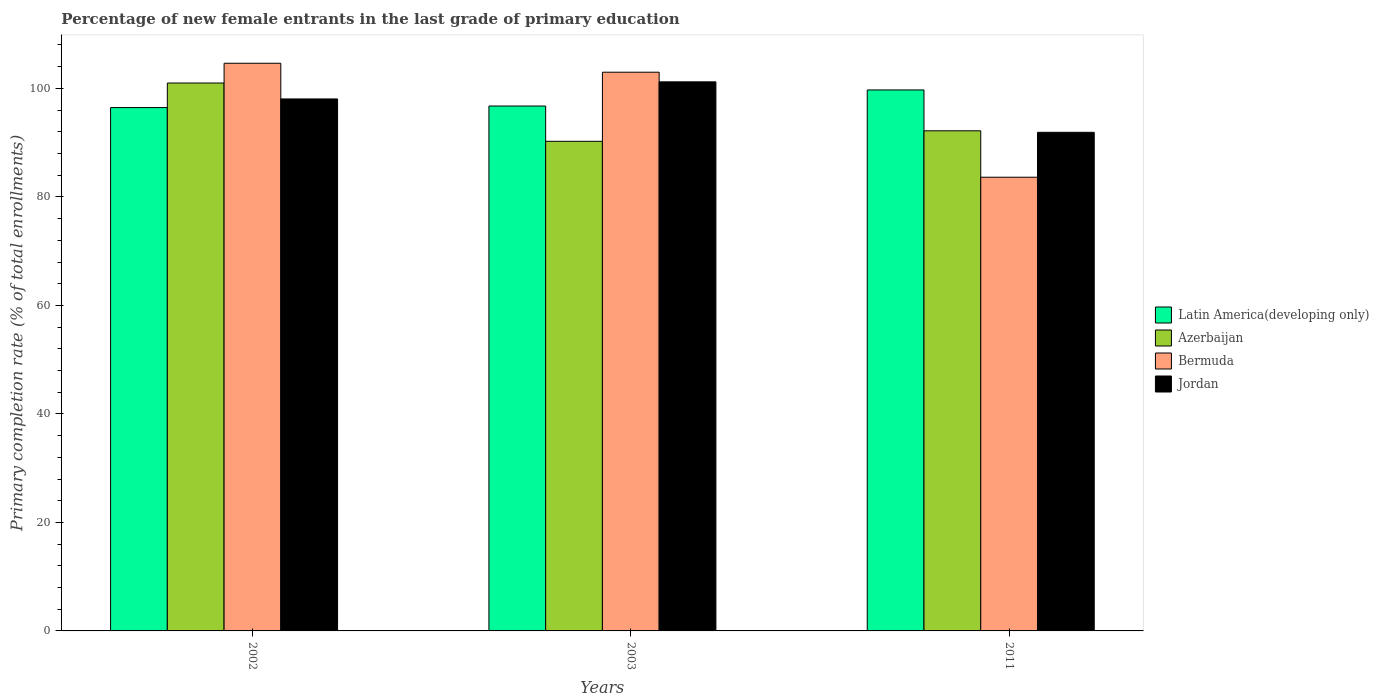How many groups of bars are there?
Offer a terse response. 3. How many bars are there on the 3rd tick from the right?
Offer a terse response. 4. What is the label of the 2nd group of bars from the left?
Keep it short and to the point. 2003. In how many cases, is the number of bars for a given year not equal to the number of legend labels?
Make the answer very short. 0. What is the percentage of new female entrants in Azerbaijan in 2002?
Ensure brevity in your answer.  100.99. Across all years, what is the maximum percentage of new female entrants in Latin America(developing only)?
Your answer should be compact. 99.72. Across all years, what is the minimum percentage of new female entrants in Jordan?
Your answer should be very brief. 91.91. In which year was the percentage of new female entrants in Jordan maximum?
Ensure brevity in your answer.  2003. In which year was the percentage of new female entrants in Latin America(developing only) minimum?
Offer a very short reply. 2002. What is the total percentage of new female entrants in Jordan in the graph?
Give a very brief answer. 291.17. What is the difference between the percentage of new female entrants in Latin America(developing only) in 2003 and that in 2011?
Your answer should be compact. -2.96. What is the difference between the percentage of new female entrants in Jordan in 2011 and the percentage of new female entrants in Bermuda in 2003?
Your answer should be very brief. -11.08. What is the average percentage of new female entrants in Bermuda per year?
Your answer should be compact. 97.08. In the year 2002, what is the difference between the percentage of new female entrants in Bermuda and percentage of new female entrants in Latin America(developing only)?
Your answer should be very brief. 8.17. What is the ratio of the percentage of new female entrants in Azerbaijan in 2002 to that in 2011?
Your answer should be very brief. 1.1. Is the percentage of new female entrants in Bermuda in 2003 less than that in 2011?
Your answer should be very brief. No. What is the difference between the highest and the second highest percentage of new female entrants in Azerbaijan?
Your response must be concise. 8.81. What is the difference between the highest and the lowest percentage of new female entrants in Azerbaijan?
Provide a succinct answer. 10.74. Is the sum of the percentage of new female entrants in Latin America(developing only) in 2003 and 2011 greater than the maximum percentage of new female entrants in Azerbaijan across all years?
Your answer should be very brief. Yes. Is it the case that in every year, the sum of the percentage of new female entrants in Azerbaijan and percentage of new female entrants in Bermuda is greater than the sum of percentage of new female entrants in Jordan and percentage of new female entrants in Latin America(developing only)?
Your answer should be compact. No. What does the 2nd bar from the left in 2002 represents?
Ensure brevity in your answer.  Azerbaijan. What does the 3rd bar from the right in 2003 represents?
Your answer should be compact. Azerbaijan. How many bars are there?
Keep it short and to the point. 12. Are all the bars in the graph horizontal?
Make the answer very short. No. How are the legend labels stacked?
Keep it short and to the point. Vertical. What is the title of the graph?
Your answer should be compact. Percentage of new female entrants in the last grade of primary education. What is the label or title of the X-axis?
Provide a short and direct response. Years. What is the label or title of the Y-axis?
Make the answer very short. Primary completion rate (% of total enrollments). What is the Primary completion rate (% of total enrollments) in Latin America(developing only) in 2002?
Ensure brevity in your answer.  96.47. What is the Primary completion rate (% of total enrollments) in Azerbaijan in 2002?
Your response must be concise. 100.99. What is the Primary completion rate (% of total enrollments) of Bermuda in 2002?
Make the answer very short. 104.63. What is the Primary completion rate (% of total enrollments) in Jordan in 2002?
Your answer should be compact. 98.06. What is the Primary completion rate (% of total enrollments) of Latin America(developing only) in 2003?
Ensure brevity in your answer.  96.75. What is the Primary completion rate (% of total enrollments) of Azerbaijan in 2003?
Ensure brevity in your answer.  90.25. What is the Primary completion rate (% of total enrollments) in Bermuda in 2003?
Ensure brevity in your answer.  102.99. What is the Primary completion rate (% of total enrollments) in Jordan in 2003?
Provide a short and direct response. 101.21. What is the Primary completion rate (% of total enrollments) of Latin America(developing only) in 2011?
Provide a succinct answer. 99.72. What is the Primary completion rate (% of total enrollments) of Azerbaijan in 2011?
Your response must be concise. 92.18. What is the Primary completion rate (% of total enrollments) of Bermuda in 2011?
Your answer should be compact. 83.63. What is the Primary completion rate (% of total enrollments) of Jordan in 2011?
Make the answer very short. 91.91. Across all years, what is the maximum Primary completion rate (% of total enrollments) in Latin America(developing only)?
Make the answer very short. 99.72. Across all years, what is the maximum Primary completion rate (% of total enrollments) of Azerbaijan?
Your answer should be compact. 100.99. Across all years, what is the maximum Primary completion rate (% of total enrollments) of Bermuda?
Offer a very short reply. 104.63. Across all years, what is the maximum Primary completion rate (% of total enrollments) in Jordan?
Your answer should be very brief. 101.21. Across all years, what is the minimum Primary completion rate (% of total enrollments) in Latin America(developing only)?
Your answer should be very brief. 96.47. Across all years, what is the minimum Primary completion rate (% of total enrollments) in Azerbaijan?
Provide a succinct answer. 90.25. Across all years, what is the minimum Primary completion rate (% of total enrollments) in Bermuda?
Your answer should be very brief. 83.63. Across all years, what is the minimum Primary completion rate (% of total enrollments) in Jordan?
Keep it short and to the point. 91.91. What is the total Primary completion rate (% of total enrollments) of Latin America(developing only) in the graph?
Keep it short and to the point. 292.93. What is the total Primary completion rate (% of total enrollments) in Azerbaijan in the graph?
Keep it short and to the point. 283.42. What is the total Primary completion rate (% of total enrollments) of Bermuda in the graph?
Make the answer very short. 291.25. What is the total Primary completion rate (% of total enrollments) in Jordan in the graph?
Provide a short and direct response. 291.17. What is the difference between the Primary completion rate (% of total enrollments) in Latin America(developing only) in 2002 and that in 2003?
Your response must be concise. -0.29. What is the difference between the Primary completion rate (% of total enrollments) in Azerbaijan in 2002 and that in 2003?
Offer a terse response. 10.74. What is the difference between the Primary completion rate (% of total enrollments) of Bermuda in 2002 and that in 2003?
Offer a very short reply. 1.65. What is the difference between the Primary completion rate (% of total enrollments) in Jordan in 2002 and that in 2003?
Offer a terse response. -3.15. What is the difference between the Primary completion rate (% of total enrollments) of Latin America(developing only) in 2002 and that in 2011?
Offer a terse response. -3.25. What is the difference between the Primary completion rate (% of total enrollments) in Azerbaijan in 2002 and that in 2011?
Keep it short and to the point. 8.81. What is the difference between the Primary completion rate (% of total enrollments) in Bermuda in 2002 and that in 2011?
Offer a terse response. 21.01. What is the difference between the Primary completion rate (% of total enrollments) of Jordan in 2002 and that in 2011?
Make the answer very short. 6.15. What is the difference between the Primary completion rate (% of total enrollments) in Latin America(developing only) in 2003 and that in 2011?
Your answer should be very brief. -2.96. What is the difference between the Primary completion rate (% of total enrollments) in Azerbaijan in 2003 and that in 2011?
Make the answer very short. -1.94. What is the difference between the Primary completion rate (% of total enrollments) of Bermuda in 2003 and that in 2011?
Offer a very short reply. 19.36. What is the difference between the Primary completion rate (% of total enrollments) in Jordan in 2003 and that in 2011?
Offer a very short reply. 9.3. What is the difference between the Primary completion rate (% of total enrollments) in Latin America(developing only) in 2002 and the Primary completion rate (% of total enrollments) in Azerbaijan in 2003?
Provide a succinct answer. 6.22. What is the difference between the Primary completion rate (% of total enrollments) in Latin America(developing only) in 2002 and the Primary completion rate (% of total enrollments) in Bermuda in 2003?
Ensure brevity in your answer.  -6.52. What is the difference between the Primary completion rate (% of total enrollments) of Latin America(developing only) in 2002 and the Primary completion rate (% of total enrollments) of Jordan in 2003?
Keep it short and to the point. -4.74. What is the difference between the Primary completion rate (% of total enrollments) of Azerbaijan in 2002 and the Primary completion rate (% of total enrollments) of Bermuda in 2003?
Offer a terse response. -1.99. What is the difference between the Primary completion rate (% of total enrollments) of Azerbaijan in 2002 and the Primary completion rate (% of total enrollments) of Jordan in 2003?
Give a very brief answer. -0.22. What is the difference between the Primary completion rate (% of total enrollments) of Bermuda in 2002 and the Primary completion rate (% of total enrollments) of Jordan in 2003?
Your answer should be very brief. 3.43. What is the difference between the Primary completion rate (% of total enrollments) of Latin America(developing only) in 2002 and the Primary completion rate (% of total enrollments) of Azerbaijan in 2011?
Your response must be concise. 4.28. What is the difference between the Primary completion rate (% of total enrollments) in Latin America(developing only) in 2002 and the Primary completion rate (% of total enrollments) in Bermuda in 2011?
Give a very brief answer. 12.84. What is the difference between the Primary completion rate (% of total enrollments) of Latin America(developing only) in 2002 and the Primary completion rate (% of total enrollments) of Jordan in 2011?
Offer a terse response. 4.56. What is the difference between the Primary completion rate (% of total enrollments) of Azerbaijan in 2002 and the Primary completion rate (% of total enrollments) of Bermuda in 2011?
Offer a terse response. 17.36. What is the difference between the Primary completion rate (% of total enrollments) in Azerbaijan in 2002 and the Primary completion rate (% of total enrollments) in Jordan in 2011?
Your answer should be very brief. 9.09. What is the difference between the Primary completion rate (% of total enrollments) of Bermuda in 2002 and the Primary completion rate (% of total enrollments) of Jordan in 2011?
Offer a terse response. 12.73. What is the difference between the Primary completion rate (% of total enrollments) of Latin America(developing only) in 2003 and the Primary completion rate (% of total enrollments) of Azerbaijan in 2011?
Provide a short and direct response. 4.57. What is the difference between the Primary completion rate (% of total enrollments) of Latin America(developing only) in 2003 and the Primary completion rate (% of total enrollments) of Bermuda in 2011?
Offer a terse response. 13.12. What is the difference between the Primary completion rate (% of total enrollments) in Latin America(developing only) in 2003 and the Primary completion rate (% of total enrollments) in Jordan in 2011?
Offer a very short reply. 4.85. What is the difference between the Primary completion rate (% of total enrollments) of Azerbaijan in 2003 and the Primary completion rate (% of total enrollments) of Bermuda in 2011?
Provide a succinct answer. 6.62. What is the difference between the Primary completion rate (% of total enrollments) of Azerbaijan in 2003 and the Primary completion rate (% of total enrollments) of Jordan in 2011?
Keep it short and to the point. -1.66. What is the difference between the Primary completion rate (% of total enrollments) of Bermuda in 2003 and the Primary completion rate (% of total enrollments) of Jordan in 2011?
Make the answer very short. 11.08. What is the average Primary completion rate (% of total enrollments) of Latin America(developing only) per year?
Provide a succinct answer. 97.64. What is the average Primary completion rate (% of total enrollments) in Azerbaijan per year?
Offer a terse response. 94.47. What is the average Primary completion rate (% of total enrollments) in Bermuda per year?
Make the answer very short. 97.08. What is the average Primary completion rate (% of total enrollments) in Jordan per year?
Give a very brief answer. 97.06. In the year 2002, what is the difference between the Primary completion rate (% of total enrollments) in Latin America(developing only) and Primary completion rate (% of total enrollments) in Azerbaijan?
Offer a very short reply. -4.53. In the year 2002, what is the difference between the Primary completion rate (% of total enrollments) of Latin America(developing only) and Primary completion rate (% of total enrollments) of Bermuda?
Offer a very short reply. -8.17. In the year 2002, what is the difference between the Primary completion rate (% of total enrollments) of Latin America(developing only) and Primary completion rate (% of total enrollments) of Jordan?
Your answer should be very brief. -1.59. In the year 2002, what is the difference between the Primary completion rate (% of total enrollments) in Azerbaijan and Primary completion rate (% of total enrollments) in Bermuda?
Offer a very short reply. -3.64. In the year 2002, what is the difference between the Primary completion rate (% of total enrollments) in Azerbaijan and Primary completion rate (% of total enrollments) in Jordan?
Ensure brevity in your answer.  2.93. In the year 2002, what is the difference between the Primary completion rate (% of total enrollments) of Bermuda and Primary completion rate (% of total enrollments) of Jordan?
Make the answer very short. 6.58. In the year 2003, what is the difference between the Primary completion rate (% of total enrollments) in Latin America(developing only) and Primary completion rate (% of total enrollments) in Azerbaijan?
Keep it short and to the point. 6.5. In the year 2003, what is the difference between the Primary completion rate (% of total enrollments) in Latin America(developing only) and Primary completion rate (% of total enrollments) in Bermuda?
Offer a terse response. -6.23. In the year 2003, what is the difference between the Primary completion rate (% of total enrollments) in Latin America(developing only) and Primary completion rate (% of total enrollments) in Jordan?
Provide a succinct answer. -4.45. In the year 2003, what is the difference between the Primary completion rate (% of total enrollments) in Azerbaijan and Primary completion rate (% of total enrollments) in Bermuda?
Your response must be concise. -12.74. In the year 2003, what is the difference between the Primary completion rate (% of total enrollments) in Azerbaijan and Primary completion rate (% of total enrollments) in Jordan?
Give a very brief answer. -10.96. In the year 2003, what is the difference between the Primary completion rate (% of total enrollments) in Bermuda and Primary completion rate (% of total enrollments) in Jordan?
Provide a succinct answer. 1.78. In the year 2011, what is the difference between the Primary completion rate (% of total enrollments) in Latin America(developing only) and Primary completion rate (% of total enrollments) in Azerbaijan?
Offer a terse response. 7.53. In the year 2011, what is the difference between the Primary completion rate (% of total enrollments) in Latin America(developing only) and Primary completion rate (% of total enrollments) in Bermuda?
Your answer should be very brief. 16.09. In the year 2011, what is the difference between the Primary completion rate (% of total enrollments) of Latin America(developing only) and Primary completion rate (% of total enrollments) of Jordan?
Ensure brevity in your answer.  7.81. In the year 2011, what is the difference between the Primary completion rate (% of total enrollments) in Azerbaijan and Primary completion rate (% of total enrollments) in Bermuda?
Give a very brief answer. 8.56. In the year 2011, what is the difference between the Primary completion rate (% of total enrollments) of Azerbaijan and Primary completion rate (% of total enrollments) of Jordan?
Your answer should be compact. 0.28. In the year 2011, what is the difference between the Primary completion rate (% of total enrollments) of Bermuda and Primary completion rate (% of total enrollments) of Jordan?
Keep it short and to the point. -8.28. What is the ratio of the Primary completion rate (% of total enrollments) of Azerbaijan in 2002 to that in 2003?
Your answer should be very brief. 1.12. What is the ratio of the Primary completion rate (% of total enrollments) in Bermuda in 2002 to that in 2003?
Give a very brief answer. 1.02. What is the ratio of the Primary completion rate (% of total enrollments) of Jordan in 2002 to that in 2003?
Ensure brevity in your answer.  0.97. What is the ratio of the Primary completion rate (% of total enrollments) in Latin America(developing only) in 2002 to that in 2011?
Provide a succinct answer. 0.97. What is the ratio of the Primary completion rate (% of total enrollments) of Azerbaijan in 2002 to that in 2011?
Provide a succinct answer. 1.1. What is the ratio of the Primary completion rate (% of total enrollments) of Bermuda in 2002 to that in 2011?
Offer a very short reply. 1.25. What is the ratio of the Primary completion rate (% of total enrollments) in Jordan in 2002 to that in 2011?
Make the answer very short. 1.07. What is the ratio of the Primary completion rate (% of total enrollments) of Latin America(developing only) in 2003 to that in 2011?
Keep it short and to the point. 0.97. What is the ratio of the Primary completion rate (% of total enrollments) in Bermuda in 2003 to that in 2011?
Make the answer very short. 1.23. What is the ratio of the Primary completion rate (% of total enrollments) in Jordan in 2003 to that in 2011?
Make the answer very short. 1.1. What is the difference between the highest and the second highest Primary completion rate (% of total enrollments) in Latin America(developing only)?
Provide a short and direct response. 2.96. What is the difference between the highest and the second highest Primary completion rate (% of total enrollments) in Azerbaijan?
Keep it short and to the point. 8.81. What is the difference between the highest and the second highest Primary completion rate (% of total enrollments) of Bermuda?
Give a very brief answer. 1.65. What is the difference between the highest and the second highest Primary completion rate (% of total enrollments) of Jordan?
Give a very brief answer. 3.15. What is the difference between the highest and the lowest Primary completion rate (% of total enrollments) of Latin America(developing only)?
Your answer should be very brief. 3.25. What is the difference between the highest and the lowest Primary completion rate (% of total enrollments) of Azerbaijan?
Your answer should be compact. 10.74. What is the difference between the highest and the lowest Primary completion rate (% of total enrollments) of Bermuda?
Give a very brief answer. 21.01. What is the difference between the highest and the lowest Primary completion rate (% of total enrollments) in Jordan?
Offer a very short reply. 9.3. 